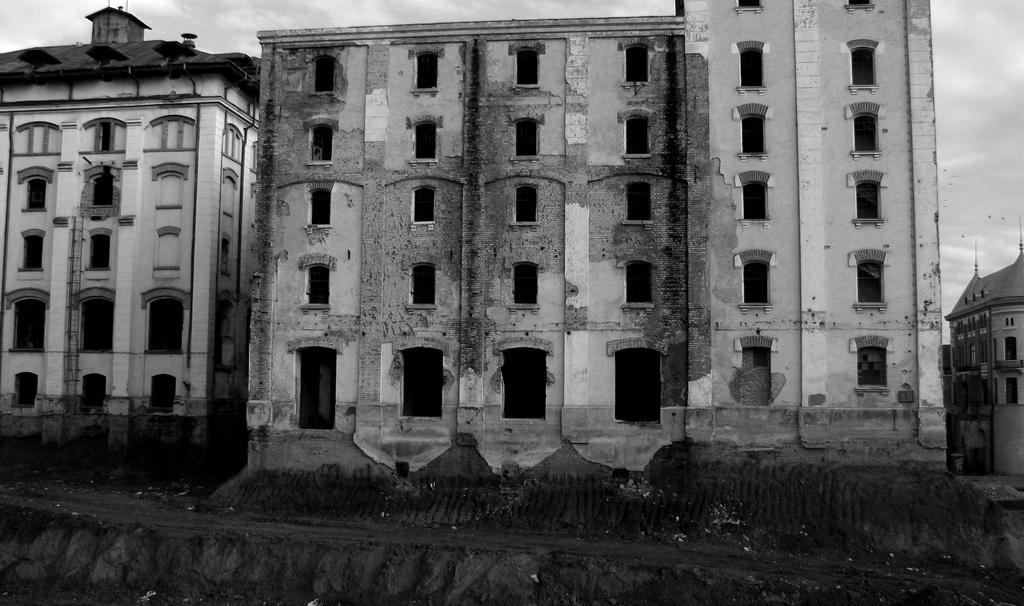What is the color scheme of the image? The image is black and white. What type of structures can be seen in the image? There are buildings in the image. What type of secretary can be seen working in the image? There is no secretary present in the image, as it only features black and white buildings. How many clams are visible on the buildings in the image? There are no clams present in the image; it only features buildings. 